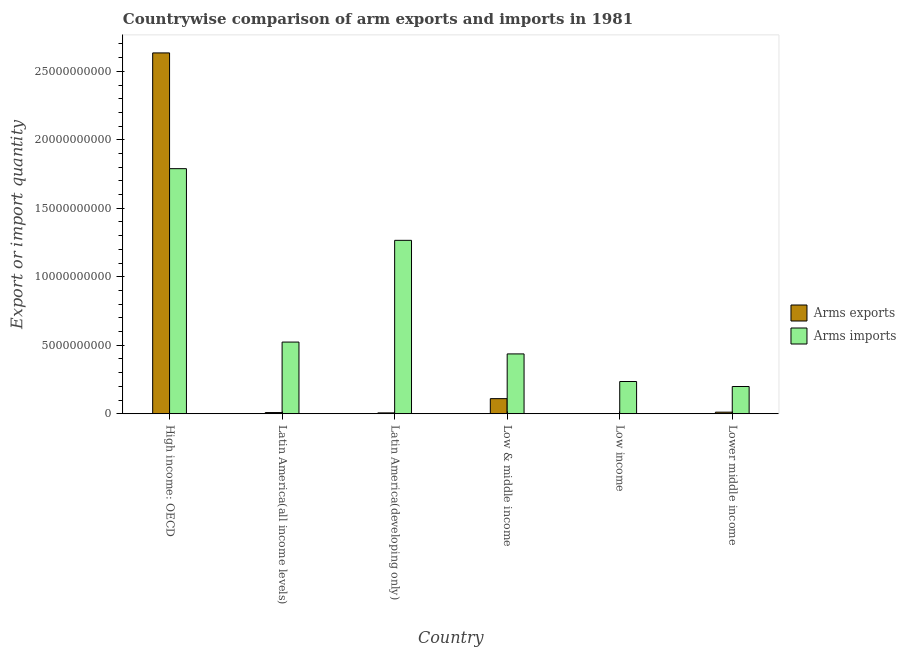How many groups of bars are there?
Offer a very short reply. 6. Are the number of bars per tick equal to the number of legend labels?
Your answer should be very brief. Yes. How many bars are there on the 3rd tick from the left?
Your response must be concise. 2. How many bars are there on the 1st tick from the right?
Offer a very short reply. 2. What is the label of the 3rd group of bars from the left?
Keep it short and to the point. Latin America(developing only). What is the arms imports in Low & middle income?
Ensure brevity in your answer.  4.37e+09. Across all countries, what is the maximum arms imports?
Your response must be concise. 1.79e+1. Across all countries, what is the minimum arms imports?
Your answer should be very brief. 1.99e+09. In which country was the arms exports maximum?
Your response must be concise. High income: OECD. In which country was the arms exports minimum?
Ensure brevity in your answer.  Low income. What is the total arms imports in the graph?
Make the answer very short. 4.45e+1. What is the difference between the arms imports in Latin America(developing only) and that in Lower middle income?
Your response must be concise. 1.07e+1. What is the difference between the arms imports in Lower middle income and the arms exports in Low income?
Your answer should be very brief. 1.98e+09. What is the average arms exports per country?
Your answer should be compact. 4.62e+09. What is the difference between the arms imports and arms exports in Low & middle income?
Your answer should be compact. 3.27e+09. In how many countries, is the arms exports greater than 14000000000 ?
Your answer should be very brief. 1. What is the ratio of the arms imports in Latin America(developing only) to that in Low & middle income?
Your response must be concise. 2.9. What is the difference between the highest and the second highest arms exports?
Your response must be concise. 2.52e+1. What is the difference between the highest and the lowest arms exports?
Your response must be concise. 2.63e+1. Is the sum of the arms imports in Latin America(developing only) and Low income greater than the maximum arms exports across all countries?
Your answer should be compact. No. What does the 2nd bar from the left in Low income represents?
Ensure brevity in your answer.  Arms imports. What does the 1st bar from the right in Low income represents?
Give a very brief answer. Arms imports. How many countries are there in the graph?
Your answer should be very brief. 6. What is the difference between two consecutive major ticks on the Y-axis?
Provide a succinct answer. 5.00e+09. Where does the legend appear in the graph?
Give a very brief answer. Center right. How many legend labels are there?
Your answer should be compact. 2. How are the legend labels stacked?
Provide a succinct answer. Vertical. What is the title of the graph?
Your response must be concise. Countrywise comparison of arm exports and imports in 1981. What is the label or title of the X-axis?
Provide a succinct answer. Country. What is the label or title of the Y-axis?
Keep it short and to the point. Export or import quantity. What is the Export or import quantity in Arms exports in High income: OECD?
Provide a short and direct response. 2.63e+1. What is the Export or import quantity of Arms imports in High income: OECD?
Make the answer very short. 1.79e+1. What is the Export or import quantity in Arms exports in Latin America(all income levels)?
Offer a terse response. 8.60e+07. What is the Export or import quantity of Arms imports in Latin America(all income levels)?
Your response must be concise. 5.23e+09. What is the Export or import quantity in Arms exports in Latin America(developing only)?
Ensure brevity in your answer.  6.20e+07. What is the Export or import quantity of Arms imports in Latin America(developing only)?
Your answer should be compact. 1.27e+1. What is the Export or import quantity in Arms exports in Low & middle income?
Keep it short and to the point. 1.10e+09. What is the Export or import quantity of Arms imports in Low & middle income?
Keep it short and to the point. 4.37e+09. What is the Export or import quantity in Arms exports in Low income?
Provide a short and direct response. 5.00e+06. What is the Export or import quantity in Arms imports in Low income?
Keep it short and to the point. 2.35e+09. What is the Export or import quantity in Arms exports in Lower middle income?
Your answer should be very brief. 1.15e+08. What is the Export or import quantity in Arms imports in Lower middle income?
Your answer should be compact. 1.99e+09. Across all countries, what is the maximum Export or import quantity in Arms exports?
Give a very brief answer. 2.63e+1. Across all countries, what is the maximum Export or import quantity of Arms imports?
Your answer should be very brief. 1.79e+1. Across all countries, what is the minimum Export or import quantity in Arms imports?
Provide a succinct answer. 1.99e+09. What is the total Export or import quantity of Arms exports in the graph?
Your answer should be compact. 2.77e+1. What is the total Export or import quantity in Arms imports in the graph?
Your response must be concise. 4.45e+1. What is the difference between the Export or import quantity of Arms exports in High income: OECD and that in Latin America(all income levels)?
Ensure brevity in your answer.  2.63e+1. What is the difference between the Export or import quantity of Arms imports in High income: OECD and that in Latin America(all income levels)?
Offer a very short reply. 1.27e+1. What is the difference between the Export or import quantity of Arms exports in High income: OECD and that in Latin America(developing only)?
Give a very brief answer. 2.63e+1. What is the difference between the Export or import quantity in Arms imports in High income: OECD and that in Latin America(developing only)?
Provide a succinct answer. 5.23e+09. What is the difference between the Export or import quantity in Arms exports in High income: OECD and that in Low & middle income?
Offer a terse response. 2.52e+1. What is the difference between the Export or import quantity in Arms imports in High income: OECD and that in Low & middle income?
Make the answer very short. 1.35e+1. What is the difference between the Export or import quantity of Arms exports in High income: OECD and that in Low income?
Offer a terse response. 2.63e+1. What is the difference between the Export or import quantity of Arms imports in High income: OECD and that in Low income?
Provide a short and direct response. 1.55e+1. What is the difference between the Export or import quantity of Arms exports in High income: OECD and that in Lower middle income?
Offer a terse response. 2.62e+1. What is the difference between the Export or import quantity of Arms imports in High income: OECD and that in Lower middle income?
Your response must be concise. 1.59e+1. What is the difference between the Export or import quantity in Arms exports in Latin America(all income levels) and that in Latin America(developing only)?
Your response must be concise. 2.40e+07. What is the difference between the Export or import quantity in Arms imports in Latin America(all income levels) and that in Latin America(developing only)?
Make the answer very short. -7.43e+09. What is the difference between the Export or import quantity of Arms exports in Latin America(all income levels) and that in Low & middle income?
Your answer should be compact. -1.02e+09. What is the difference between the Export or import quantity in Arms imports in Latin America(all income levels) and that in Low & middle income?
Your answer should be compact. 8.65e+08. What is the difference between the Export or import quantity in Arms exports in Latin America(all income levels) and that in Low income?
Your answer should be compact. 8.10e+07. What is the difference between the Export or import quantity of Arms imports in Latin America(all income levels) and that in Low income?
Your answer should be compact. 2.88e+09. What is the difference between the Export or import quantity of Arms exports in Latin America(all income levels) and that in Lower middle income?
Give a very brief answer. -2.90e+07. What is the difference between the Export or import quantity in Arms imports in Latin America(all income levels) and that in Lower middle income?
Give a very brief answer. 3.24e+09. What is the difference between the Export or import quantity of Arms exports in Latin America(developing only) and that in Low & middle income?
Provide a succinct answer. -1.04e+09. What is the difference between the Export or import quantity in Arms imports in Latin America(developing only) and that in Low & middle income?
Keep it short and to the point. 8.29e+09. What is the difference between the Export or import quantity in Arms exports in Latin America(developing only) and that in Low income?
Provide a short and direct response. 5.70e+07. What is the difference between the Export or import quantity in Arms imports in Latin America(developing only) and that in Low income?
Make the answer very short. 1.03e+1. What is the difference between the Export or import quantity in Arms exports in Latin America(developing only) and that in Lower middle income?
Offer a very short reply. -5.30e+07. What is the difference between the Export or import quantity of Arms imports in Latin America(developing only) and that in Lower middle income?
Your response must be concise. 1.07e+1. What is the difference between the Export or import quantity of Arms exports in Low & middle income and that in Low income?
Make the answer very short. 1.10e+09. What is the difference between the Export or import quantity of Arms imports in Low & middle income and that in Low income?
Your response must be concise. 2.02e+09. What is the difference between the Export or import quantity in Arms exports in Low & middle income and that in Lower middle income?
Give a very brief answer. 9.87e+08. What is the difference between the Export or import quantity of Arms imports in Low & middle income and that in Lower middle income?
Ensure brevity in your answer.  2.38e+09. What is the difference between the Export or import quantity of Arms exports in Low income and that in Lower middle income?
Keep it short and to the point. -1.10e+08. What is the difference between the Export or import quantity in Arms imports in Low income and that in Lower middle income?
Your response must be concise. 3.65e+08. What is the difference between the Export or import quantity of Arms exports in High income: OECD and the Export or import quantity of Arms imports in Latin America(all income levels)?
Your answer should be very brief. 2.11e+1. What is the difference between the Export or import quantity of Arms exports in High income: OECD and the Export or import quantity of Arms imports in Latin America(developing only)?
Ensure brevity in your answer.  1.37e+1. What is the difference between the Export or import quantity of Arms exports in High income: OECD and the Export or import quantity of Arms imports in Low & middle income?
Ensure brevity in your answer.  2.20e+1. What is the difference between the Export or import quantity in Arms exports in High income: OECD and the Export or import quantity in Arms imports in Low income?
Ensure brevity in your answer.  2.40e+1. What is the difference between the Export or import quantity in Arms exports in High income: OECD and the Export or import quantity in Arms imports in Lower middle income?
Offer a very short reply. 2.44e+1. What is the difference between the Export or import quantity in Arms exports in Latin America(all income levels) and the Export or import quantity in Arms imports in Latin America(developing only)?
Offer a very short reply. -1.26e+1. What is the difference between the Export or import quantity of Arms exports in Latin America(all income levels) and the Export or import quantity of Arms imports in Low & middle income?
Provide a succinct answer. -4.28e+09. What is the difference between the Export or import quantity of Arms exports in Latin America(all income levels) and the Export or import quantity of Arms imports in Low income?
Your answer should be very brief. -2.27e+09. What is the difference between the Export or import quantity of Arms exports in Latin America(all income levels) and the Export or import quantity of Arms imports in Lower middle income?
Give a very brief answer. -1.90e+09. What is the difference between the Export or import quantity in Arms exports in Latin America(developing only) and the Export or import quantity in Arms imports in Low & middle income?
Give a very brief answer. -4.31e+09. What is the difference between the Export or import quantity in Arms exports in Latin America(developing only) and the Export or import quantity in Arms imports in Low income?
Make the answer very short. -2.29e+09. What is the difference between the Export or import quantity in Arms exports in Latin America(developing only) and the Export or import quantity in Arms imports in Lower middle income?
Provide a succinct answer. -1.93e+09. What is the difference between the Export or import quantity in Arms exports in Low & middle income and the Export or import quantity in Arms imports in Low income?
Your answer should be very brief. -1.25e+09. What is the difference between the Export or import quantity in Arms exports in Low & middle income and the Export or import quantity in Arms imports in Lower middle income?
Keep it short and to the point. -8.86e+08. What is the difference between the Export or import quantity in Arms exports in Low income and the Export or import quantity in Arms imports in Lower middle income?
Provide a succinct answer. -1.98e+09. What is the average Export or import quantity in Arms exports per country?
Offer a terse response. 4.62e+09. What is the average Export or import quantity of Arms imports per country?
Your answer should be very brief. 7.42e+09. What is the difference between the Export or import quantity in Arms exports and Export or import quantity in Arms imports in High income: OECD?
Offer a very short reply. 8.45e+09. What is the difference between the Export or import quantity in Arms exports and Export or import quantity in Arms imports in Latin America(all income levels)?
Ensure brevity in your answer.  -5.15e+09. What is the difference between the Export or import quantity in Arms exports and Export or import quantity in Arms imports in Latin America(developing only)?
Offer a very short reply. -1.26e+1. What is the difference between the Export or import quantity of Arms exports and Export or import quantity of Arms imports in Low & middle income?
Offer a very short reply. -3.27e+09. What is the difference between the Export or import quantity of Arms exports and Export or import quantity of Arms imports in Low income?
Your answer should be compact. -2.35e+09. What is the difference between the Export or import quantity of Arms exports and Export or import quantity of Arms imports in Lower middle income?
Keep it short and to the point. -1.87e+09. What is the ratio of the Export or import quantity of Arms exports in High income: OECD to that in Latin America(all income levels)?
Give a very brief answer. 306.33. What is the ratio of the Export or import quantity of Arms imports in High income: OECD to that in Latin America(all income levels)?
Your response must be concise. 3.42. What is the ratio of the Export or import quantity in Arms exports in High income: OECD to that in Latin America(developing only)?
Make the answer very short. 424.9. What is the ratio of the Export or import quantity of Arms imports in High income: OECD to that in Latin America(developing only)?
Your answer should be compact. 1.41. What is the ratio of the Export or import quantity of Arms exports in High income: OECD to that in Low & middle income?
Your response must be concise. 23.91. What is the ratio of the Export or import quantity of Arms imports in High income: OECD to that in Low & middle income?
Your answer should be compact. 4.1. What is the ratio of the Export or import quantity of Arms exports in High income: OECD to that in Low income?
Your response must be concise. 5268.8. What is the ratio of the Export or import quantity of Arms imports in High income: OECD to that in Low income?
Your answer should be very brief. 7.6. What is the ratio of the Export or import quantity in Arms exports in High income: OECD to that in Lower middle income?
Give a very brief answer. 229.08. What is the ratio of the Export or import quantity of Arms imports in High income: OECD to that in Lower middle income?
Provide a succinct answer. 9. What is the ratio of the Export or import quantity of Arms exports in Latin America(all income levels) to that in Latin America(developing only)?
Provide a succinct answer. 1.39. What is the ratio of the Export or import quantity of Arms imports in Latin America(all income levels) to that in Latin America(developing only)?
Offer a very short reply. 0.41. What is the ratio of the Export or import quantity in Arms exports in Latin America(all income levels) to that in Low & middle income?
Make the answer very short. 0.08. What is the ratio of the Export or import quantity of Arms imports in Latin America(all income levels) to that in Low & middle income?
Give a very brief answer. 1.2. What is the ratio of the Export or import quantity of Arms imports in Latin America(all income levels) to that in Low income?
Offer a very short reply. 2.22. What is the ratio of the Export or import quantity in Arms exports in Latin America(all income levels) to that in Lower middle income?
Provide a short and direct response. 0.75. What is the ratio of the Export or import quantity of Arms imports in Latin America(all income levels) to that in Lower middle income?
Your answer should be compact. 2.63. What is the ratio of the Export or import quantity in Arms exports in Latin America(developing only) to that in Low & middle income?
Your answer should be compact. 0.06. What is the ratio of the Export or import quantity of Arms imports in Latin America(developing only) to that in Low & middle income?
Your response must be concise. 2.9. What is the ratio of the Export or import quantity in Arms exports in Latin America(developing only) to that in Low income?
Offer a very short reply. 12.4. What is the ratio of the Export or import quantity in Arms imports in Latin America(developing only) to that in Low income?
Make the answer very short. 5.38. What is the ratio of the Export or import quantity of Arms exports in Latin America(developing only) to that in Lower middle income?
Your response must be concise. 0.54. What is the ratio of the Export or import quantity in Arms imports in Latin America(developing only) to that in Lower middle income?
Keep it short and to the point. 6.37. What is the ratio of the Export or import quantity of Arms exports in Low & middle income to that in Low income?
Give a very brief answer. 220.4. What is the ratio of the Export or import quantity in Arms imports in Low & middle income to that in Low income?
Keep it short and to the point. 1.86. What is the ratio of the Export or import quantity in Arms exports in Low & middle income to that in Lower middle income?
Your answer should be compact. 9.58. What is the ratio of the Export or import quantity of Arms imports in Low & middle income to that in Lower middle income?
Keep it short and to the point. 2.2. What is the ratio of the Export or import quantity of Arms exports in Low income to that in Lower middle income?
Make the answer very short. 0.04. What is the ratio of the Export or import quantity in Arms imports in Low income to that in Lower middle income?
Keep it short and to the point. 1.18. What is the difference between the highest and the second highest Export or import quantity of Arms exports?
Keep it short and to the point. 2.52e+1. What is the difference between the highest and the second highest Export or import quantity of Arms imports?
Offer a very short reply. 5.23e+09. What is the difference between the highest and the lowest Export or import quantity in Arms exports?
Provide a succinct answer. 2.63e+1. What is the difference between the highest and the lowest Export or import quantity in Arms imports?
Keep it short and to the point. 1.59e+1. 